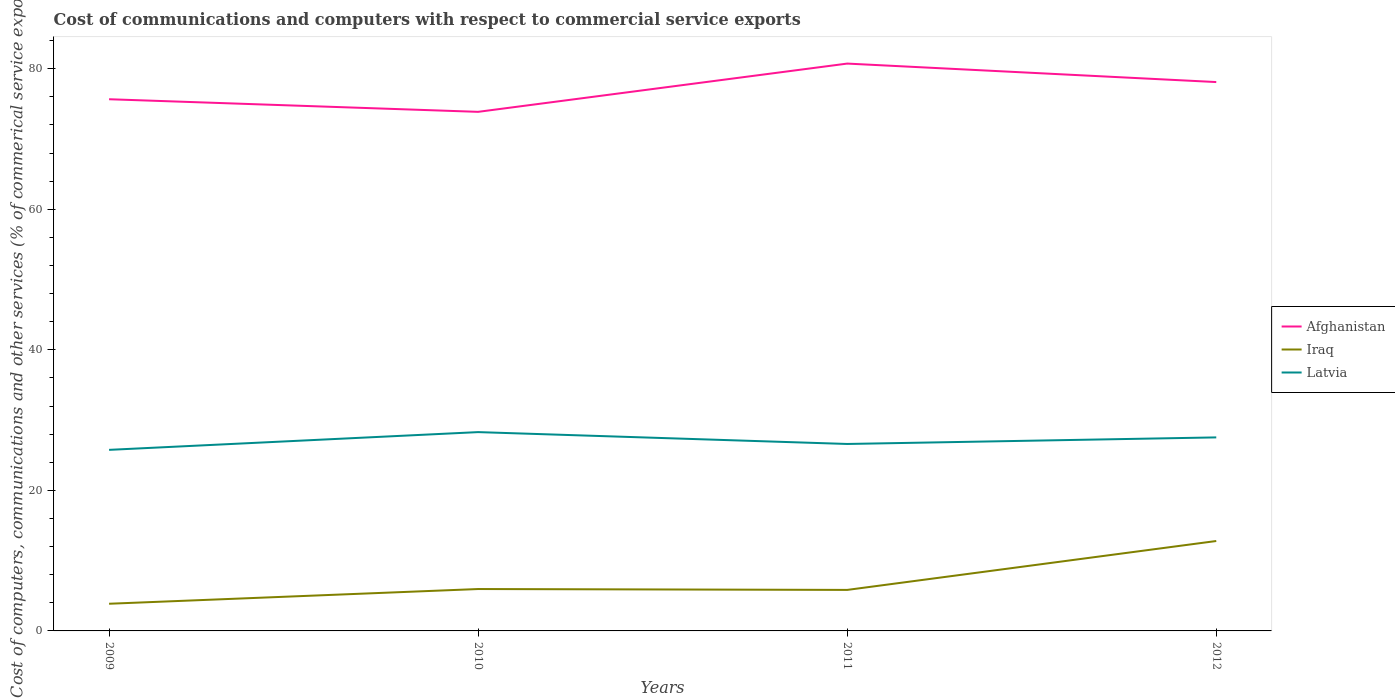Does the line corresponding to Latvia intersect with the line corresponding to Iraq?
Make the answer very short. No. Is the number of lines equal to the number of legend labels?
Offer a terse response. Yes. Across all years, what is the maximum cost of communications and computers in Latvia?
Make the answer very short. 25.77. In which year was the cost of communications and computers in Afghanistan maximum?
Your answer should be compact. 2010. What is the total cost of communications and computers in Latvia in the graph?
Offer a terse response. 0.75. What is the difference between the highest and the second highest cost of communications and computers in Afghanistan?
Ensure brevity in your answer.  6.87. What is the difference between the highest and the lowest cost of communications and computers in Afghanistan?
Provide a succinct answer. 2. Is the cost of communications and computers in Afghanistan strictly greater than the cost of communications and computers in Iraq over the years?
Your answer should be very brief. No. How many years are there in the graph?
Ensure brevity in your answer.  4. What is the difference between two consecutive major ticks on the Y-axis?
Offer a terse response. 20. Does the graph contain any zero values?
Ensure brevity in your answer.  No. How are the legend labels stacked?
Your answer should be compact. Vertical. What is the title of the graph?
Give a very brief answer. Cost of communications and computers with respect to commercial service exports. Does "Eritrea" appear as one of the legend labels in the graph?
Your answer should be very brief. No. What is the label or title of the X-axis?
Make the answer very short. Years. What is the label or title of the Y-axis?
Your answer should be very brief. Cost of computers, communications and other services (% of commerical service exports). What is the Cost of computers, communications and other services (% of commerical service exports) in Afghanistan in 2009?
Your answer should be very brief. 75.66. What is the Cost of computers, communications and other services (% of commerical service exports) of Iraq in 2009?
Offer a very short reply. 3.87. What is the Cost of computers, communications and other services (% of commerical service exports) in Latvia in 2009?
Provide a short and direct response. 25.77. What is the Cost of computers, communications and other services (% of commerical service exports) in Afghanistan in 2010?
Offer a terse response. 73.87. What is the Cost of computers, communications and other services (% of commerical service exports) in Iraq in 2010?
Offer a terse response. 5.96. What is the Cost of computers, communications and other services (% of commerical service exports) of Latvia in 2010?
Give a very brief answer. 28.29. What is the Cost of computers, communications and other services (% of commerical service exports) of Afghanistan in 2011?
Provide a short and direct response. 80.74. What is the Cost of computers, communications and other services (% of commerical service exports) in Iraq in 2011?
Keep it short and to the point. 5.84. What is the Cost of computers, communications and other services (% of commerical service exports) in Latvia in 2011?
Offer a terse response. 26.6. What is the Cost of computers, communications and other services (% of commerical service exports) in Afghanistan in 2012?
Keep it short and to the point. 78.11. What is the Cost of computers, communications and other services (% of commerical service exports) of Iraq in 2012?
Provide a succinct answer. 12.8. What is the Cost of computers, communications and other services (% of commerical service exports) in Latvia in 2012?
Make the answer very short. 27.54. Across all years, what is the maximum Cost of computers, communications and other services (% of commerical service exports) of Afghanistan?
Your answer should be very brief. 80.74. Across all years, what is the maximum Cost of computers, communications and other services (% of commerical service exports) in Iraq?
Provide a short and direct response. 12.8. Across all years, what is the maximum Cost of computers, communications and other services (% of commerical service exports) of Latvia?
Offer a terse response. 28.29. Across all years, what is the minimum Cost of computers, communications and other services (% of commerical service exports) of Afghanistan?
Ensure brevity in your answer.  73.87. Across all years, what is the minimum Cost of computers, communications and other services (% of commerical service exports) of Iraq?
Provide a short and direct response. 3.87. Across all years, what is the minimum Cost of computers, communications and other services (% of commerical service exports) of Latvia?
Provide a short and direct response. 25.77. What is the total Cost of computers, communications and other services (% of commerical service exports) of Afghanistan in the graph?
Offer a terse response. 308.38. What is the total Cost of computers, communications and other services (% of commerical service exports) in Iraq in the graph?
Your answer should be compact. 28.46. What is the total Cost of computers, communications and other services (% of commerical service exports) in Latvia in the graph?
Your answer should be very brief. 108.2. What is the difference between the Cost of computers, communications and other services (% of commerical service exports) of Afghanistan in 2009 and that in 2010?
Your answer should be compact. 1.79. What is the difference between the Cost of computers, communications and other services (% of commerical service exports) of Iraq in 2009 and that in 2010?
Your response must be concise. -2.09. What is the difference between the Cost of computers, communications and other services (% of commerical service exports) in Latvia in 2009 and that in 2010?
Give a very brief answer. -2.53. What is the difference between the Cost of computers, communications and other services (% of commerical service exports) in Afghanistan in 2009 and that in 2011?
Make the answer very short. -5.07. What is the difference between the Cost of computers, communications and other services (% of commerical service exports) in Iraq in 2009 and that in 2011?
Make the answer very short. -1.97. What is the difference between the Cost of computers, communications and other services (% of commerical service exports) of Latvia in 2009 and that in 2011?
Ensure brevity in your answer.  -0.84. What is the difference between the Cost of computers, communications and other services (% of commerical service exports) of Afghanistan in 2009 and that in 2012?
Provide a short and direct response. -2.44. What is the difference between the Cost of computers, communications and other services (% of commerical service exports) in Iraq in 2009 and that in 2012?
Offer a very short reply. -8.93. What is the difference between the Cost of computers, communications and other services (% of commerical service exports) in Latvia in 2009 and that in 2012?
Offer a terse response. -1.77. What is the difference between the Cost of computers, communications and other services (% of commerical service exports) in Afghanistan in 2010 and that in 2011?
Your answer should be compact. -6.87. What is the difference between the Cost of computers, communications and other services (% of commerical service exports) in Iraq in 2010 and that in 2011?
Your answer should be compact. 0.13. What is the difference between the Cost of computers, communications and other services (% of commerical service exports) in Latvia in 2010 and that in 2011?
Ensure brevity in your answer.  1.69. What is the difference between the Cost of computers, communications and other services (% of commerical service exports) of Afghanistan in 2010 and that in 2012?
Your answer should be very brief. -4.24. What is the difference between the Cost of computers, communications and other services (% of commerical service exports) in Iraq in 2010 and that in 2012?
Your answer should be very brief. -6.83. What is the difference between the Cost of computers, communications and other services (% of commerical service exports) in Latvia in 2010 and that in 2012?
Keep it short and to the point. 0.75. What is the difference between the Cost of computers, communications and other services (% of commerical service exports) in Afghanistan in 2011 and that in 2012?
Provide a succinct answer. 2.63. What is the difference between the Cost of computers, communications and other services (% of commerical service exports) of Iraq in 2011 and that in 2012?
Make the answer very short. -6.96. What is the difference between the Cost of computers, communications and other services (% of commerical service exports) of Latvia in 2011 and that in 2012?
Ensure brevity in your answer.  -0.94. What is the difference between the Cost of computers, communications and other services (% of commerical service exports) of Afghanistan in 2009 and the Cost of computers, communications and other services (% of commerical service exports) of Iraq in 2010?
Your answer should be compact. 69.7. What is the difference between the Cost of computers, communications and other services (% of commerical service exports) in Afghanistan in 2009 and the Cost of computers, communications and other services (% of commerical service exports) in Latvia in 2010?
Your answer should be compact. 47.37. What is the difference between the Cost of computers, communications and other services (% of commerical service exports) of Iraq in 2009 and the Cost of computers, communications and other services (% of commerical service exports) of Latvia in 2010?
Keep it short and to the point. -24.43. What is the difference between the Cost of computers, communications and other services (% of commerical service exports) of Afghanistan in 2009 and the Cost of computers, communications and other services (% of commerical service exports) of Iraq in 2011?
Give a very brief answer. 69.83. What is the difference between the Cost of computers, communications and other services (% of commerical service exports) in Afghanistan in 2009 and the Cost of computers, communications and other services (% of commerical service exports) in Latvia in 2011?
Provide a succinct answer. 49.06. What is the difference between the Cost of computers, communications and other services (% of commerical service exports) of Iraq in 2009 and the Cost of computers, communications and other services (% of commerical service exports) of Latvia in 2011?
Your response must be concise. -22.74. What is the difference between the Cost of computers, communications and other services (% of commerical service exports) of Afghanistan in 2009 and the Cost of computers, communications and other services (% of commerical service exports) of Iraq in 2012?
Provide a succinct answer. 62.87. What is the difference between the Cost of computers, communications and other services (% of commerical service exports) in Afghanistan in 2009 and the Cost of computers, communications and other services (% of commerical service exports) in Latvia in 2012?
Ensure brevity in your answer.  48.12. What is the difference between the Cost of computers, communications and other services (% of commerical service exports) in Iraq in 2009 and the Cost of computers, communications and other services (% of commerical service exports) in Latvia in 2012?
Make the answer very short. -23.67. What is the difference between the Cost of computers, communications and other services (% of commerical service exports) of Afghanistan in 2010 and the Cost of computers, communications and other services (% of commerical service exports) of Iraq in 2011?
Offer a very short reply. 68.03. What is the difference between the Cost of computers, communications and other services (% of commerical service exports) in Afghanistan in 2010 and the Cost of computers, communications and other services (% of commerical service exports) in Latvia in 2011?
Offer a terse response. 47.27. What is the difference between the Cost of computers, communications and other services (% of commerical service exports) of Iraq in 2010 and the Cost of computers, communications and other services (% of commerical service exports) of Latvia in 2011?
Make the answer very short. -20.64. What is the difference between the Cost of computers, communications and other services (% of commerical service exports) in Afghanistan in 2010 and the Cost of computers, communications and other services (% of commerical service exports) in Iraq in 2012?
Your answer should be very brief. 61.07. What is the difference between the Cost of computers, communications and other services (% of commerical service exports) of Afghanistan in 2010 and the Cost of computers, communications and other services (% of commerical service exports) of Latvia in 2012?
Offer a very short reply. 46.33. What is the difference between the Cost of computers, communications and other services (% of commerical service exports) in Iraq in 2010 and the Cost of computers, communications and other services (% of commerical service exports) in Latvia in 2012?
Offer a very short reply. -21.58. What is the difference between the Cost of computers, communications and other services (% of commerical service exports) of Afghanistan in 2011 and the Cost of computers, communications and other services (% of commerical service exports) of Iraq in 2012?
Offer a very short reply. 67.94. What is the difference between the Cost of computers, communications and other services (% of commerical service exports) in Afghanistan in 2011 and the Cost of computers, communications and other services (% of commerical service exports) in Latvia in 2012?
Keep it short and to the point. 53.2. What is the difference between the Cost of computers, communications and other services (% of commerical service exports) of Iraq in 2011 and the Cost of computers, communications and other services (% of commerical service exports) of Latvia in 2012?
Make the answer very short. -21.7. What is the average Cost of computers, communications and other services (% of commerical service exports) in Afghanistan per year?
Keep it short and to the point. 77.1. What is the average Cost of computers, communications and other services (% of commerical service exports) of Iraq per year?
Make the answer very short. 7.12. What is the average Cost of computers, communications and other services (% of commerical service exports) in Latvia per year?
Provide a short and direct response. 27.05. In the year 2009, what is the difference between the Cost of computers, communications and other services (% of commerical service exports) in Afghanistan and Cost of computers, communications and other services (% of commerical service exports) in Iraq?
Make the answer very short. 71.8. In the year 2009, what is the difference between the Cost of computers, communications and other services (% of commerical service exports) in Afghanistan and Cost of computers, communications and other services (% of commerical service exports) in Latvia?
Provide a short and direct response. 49.9. In the year 2009, what is the difference between the Cost of computers, communications and other services (% of commerical service exports) of Iraq and Cost of computers, communications and other services (% of commerical service exports) of Latvia?
Your response must be concise. -21.9. In the year 2010, what is the difference between the Cost of computers, communications and other services (% of commerical service exports) in Afghanistan and Cost of computers, communications and other services (% of commerical service exports) in Iraq?
Ensure brevity in your answer.  67.91. In the year 2010, what is the difference between the Cost of computers, communications and other services (% of commerical service exports) in Afghanistan and Cost of computers, communications and other services (% of commerical service exports) in Latvia?
Your answer should be compact. 45.58. In the year 2010, what is the difference between the Cost of computers, communications and other services (% of commerical service exports) in Iraq and Cost of computers, communications and other services (% of commerical service exports) in Latvia?
Your response must be concise. -22.33. In the year 2011, what is the difference between the Cost of computers, communications and other services (% of commerical service exports) of Afghanistan and Cost of computers, communications and other services (% of commerical service exports) of Iraq?
Your answer should be very brief. 74.9. In the year 2011, what is the difference between the Cost of computers, communications and other services (% of commerical service exports) of Afghanistan and Cost of computers, communications and other services (% of commerical service exports) of Latvia?
Make the answer very short. 54.13. In the year 2011, what is the difference between the Cost of computers, communications and other services (% of commerical service exports) in Iraq and Cost of computers, communications and other services (% of commerical service exports) in Latvia?
Offer a very short reply. -20.77. In the year 2012, what is the difference between the Cost of computers, communications and other services (% of commerical service exports) in Afghanistan and Cost of computers, communications and other services (% of commerical service exports) in Iraq?
Keep it short and to the point. 65.31. In the year 2012, what is the difference between the Cost of computers, communications and other services (% of commerical service exports) of Afghanistan and Cost of computers, communications and other services (% of commerical service exports) of Latvia?
Ensure brevity in your answer.  50.57. In the year 2012, what is the difference between the Cost of computers, communications and other services (% of commerical service exports) of Iraq and Cost of computers, communications and other services (% of commerical service exports) of Latvia?
Your answer should be compact. -14.74. What is the ratio of the Cost of computers, communications and other services (% of commerical service exports) of Afghanistan in 2009 to that in 2010?
Offer a terse response. 1.02. What is the ratio of the Cost of computers, communications and other services (% of commerical service exports) of Iraq in 2009 to that in 2010?
Provide a succinct answer. 0.65. What is the ratio of the Cost of computers, communications and other services (% of commerical service exports) in Latvia in 2009 to that in 2010?
Your answer should be very brief. 0.91. What is the ratio of the Cost of computers, communications and other services (% of commerical service exports) in Afghanistan in 2009 to that in 2011?
Give a very brief answer. 0.94. What is the ratio of the Cost of computers, communications and other services (% of commerical service exports) of Iraq in 2009 to that in 2011?
Provide a succinct answer. 0.66. What is the ratio of the Cost of computers, communications and other services (% of commerical service exports) of Latvia in 2009 to that in 2011?
Provide a succinct answer. 0.97. What is the ratio of the Cost of computers, communications and other services (% of commerical service exports) in Afghanistan in 2009 to that in 2012?
Your response must be concise. 0.97. What is the ratio of the Cost of computers, communications and other services (% of commerical service exports) in Iraq in 2009 to that in 2012?
Your response must be concise. 0.3. What is the ratio of the Cost of computers, communications and other services (% of commerical service exports) in Latvia in 2009 to that in 2012?
Make the answer very short. 0.94. What is the ratio of the Cost of computers, communications and other services (% of commerical service exports) of Afghanistan in 2010 to that in 2011?
Offer a terse response. 0.91. What is the ratio of the Cost of computers, communications and other services (% of commerical service exports) of Iraq in 2010 to that in 2011?
Your answer should be very brief. 1.02. What is the ratio of the Cost of computers, communications and other services (% of commerical service exports) of Latvia in 2010 to that in 2011?
Keep it short and to the point. 1.06. What is the ratio of the Cost of computers, communications and other services (% of commerical service exports) of Afghanistan in 2010 to that in 2012?
Give a very brief answer. 0.95. What is the ratio of the Cost of computers, communications and other services (% of commerical service exports) in Iraq in 2010 to that in 2012?
Offer a very short reply. 0.47. What is the ratio of the Cost of computers, communications and other services (% of commerical service exports) in Latvia in 2010 to that in 2012?
Your answer should be compact. 1.03. What is the ratio of the Cost of computers, communications and other services (% of commerical service exports) of Afghanistan in 2011 to that in 2012?
Provide a short and direct response. 1.03. What is the ratio of the Cost of computers, communications and other services (% of commerical service exports) in Iraq in 2011 to that in 2012?
Your response must be concise. 0.46. What is the difference between the highest and the second highest Cost of computers, communications and other services (% of commerical service exports) of Afghanistan?
Offer a terse response. 2.63. What is the difference between the highest and the second highest Cost of computers, communications and other services (% of commerical service exports) of Iraq?
Give a very brief answer. 6.83. What is the difference between the highest and the second highest Cost of computers, communications and other services (% of commerical service exports) in Latvia?
Provide a short and direct response. 0.75. What is the difference between the highest and the lowest Cost of computers, communications and other services (% of commerical service exports) in Afghanistan?
Offer a very short reply. 6.87. What is the difference between the highest and the lowest Cost of computers, communications and other services (% of commerical service exports) in Iraq?
Provide a short and direct response. 8.93. What is the difference between the highest and the lowest Cost of computers, communications and other services (% of commerical service exports) of Latvia?
Offer a very short reply. 2.53. 